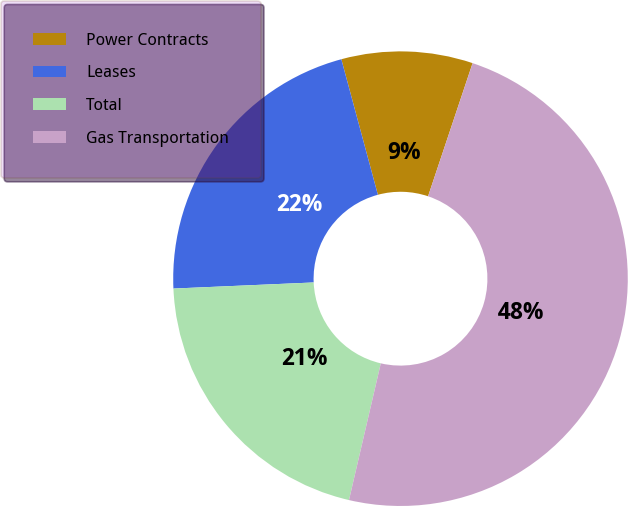Convert chart. <chart><loc_0><loc_0><loc_500><loc_500><pie_chart><fcel>Power Contracts<fcel>Leases<fcel>Total<fcel>Gas Transportation<nl><fcel>9.33%<fcel>21.5%<fcel>20.67%<fcel>48.5%<nl></chart> 